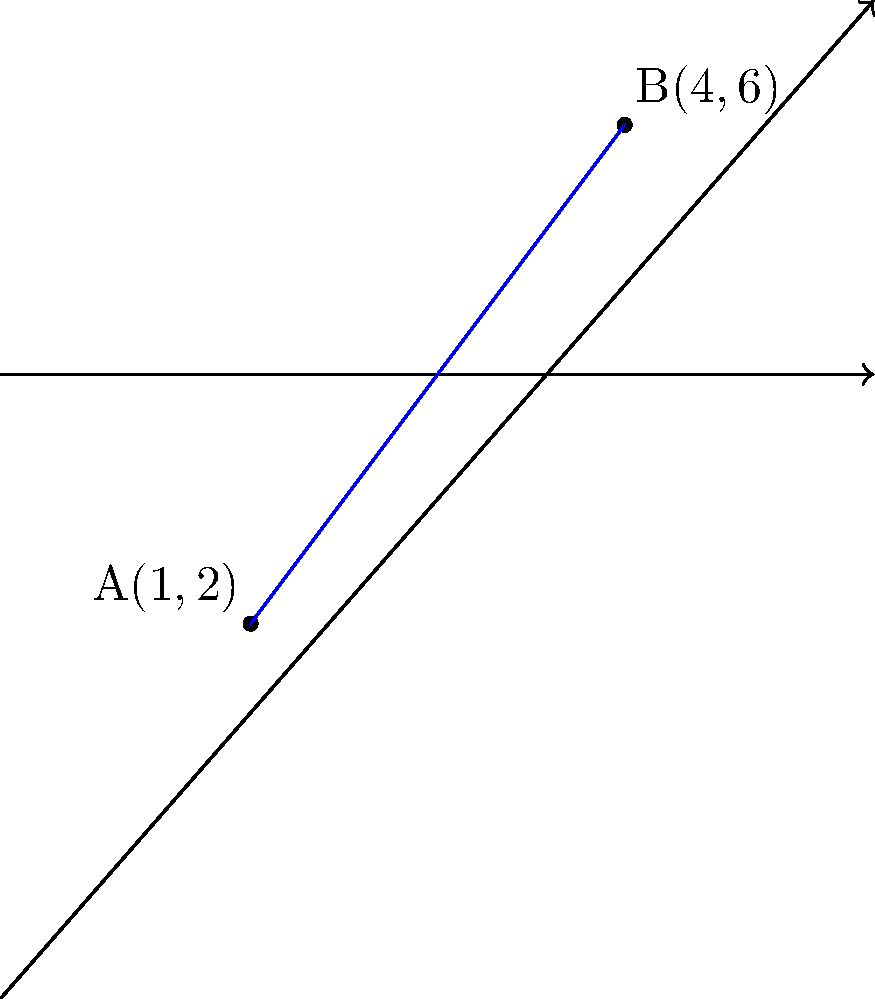In Daniel Chacón's poetic universe, two characters are represented as points on a coordinate plane. Character A is located at (1,2) and Character B is at (4,6). What is the distance between these two characters, symbolizing their emotional connection in Chacón's narrative? To find the distance between two points on a coordinate plane, we use the distance formula, which is derived from the Pythagorean theorem:

$$d = \sqrt{(x_2 - x_1)^2 + (y_2 - y_1)^2}$$

Where $(x_1, y_1)$ are the coordinates of the first point and $(x_2, y_2)$ are the coordinates of the second point.

Let's plug in our values:
$A(x_1, y_1) = (1, 2)$
$B(x_2, y_2) = (4, 6)$

Now, let's calculate:

1) $x_2 - x_1 = 4 - 1 = 3$
2) $y_2 - y_1 = 6 - 2 = 4$

Plugging these into our formula:

$$d = \sqrt{(3)^2 + (4)^2}$$

3) $d = \sqrt{9 + 16}$
4) $d = \sqrt{25}$
5) $d = 5$

Therefore, the distance between the two characters is 5 units.
Answer: 5 units 